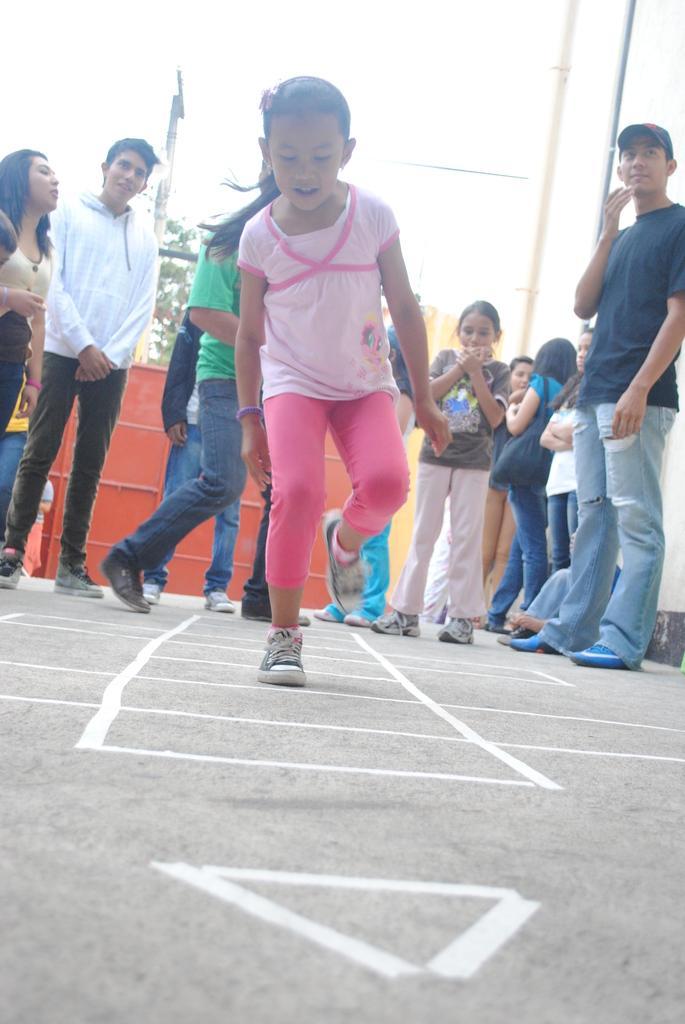Can you describe this image briefly? This image is taken outdoors. At the bottom of the image there is a road. In the background there is a tree and there is a tree. There is a fence. A few people are standing on the road and a man is walking. In the middle of the image a kid is hopping on the road. On the right side of the image there are two poles. 